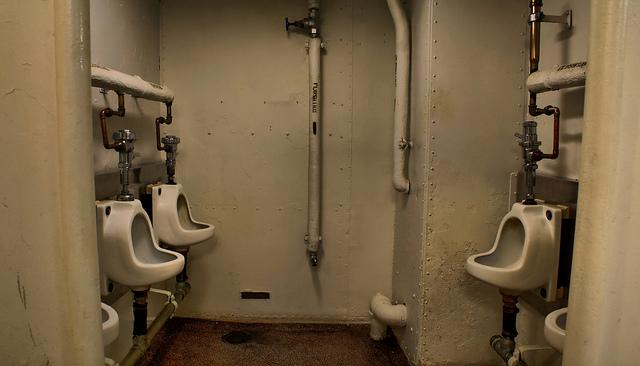What does the urinals use to wash away human waste? Please explain your reasoning. waster. Waste gets flushed away. 